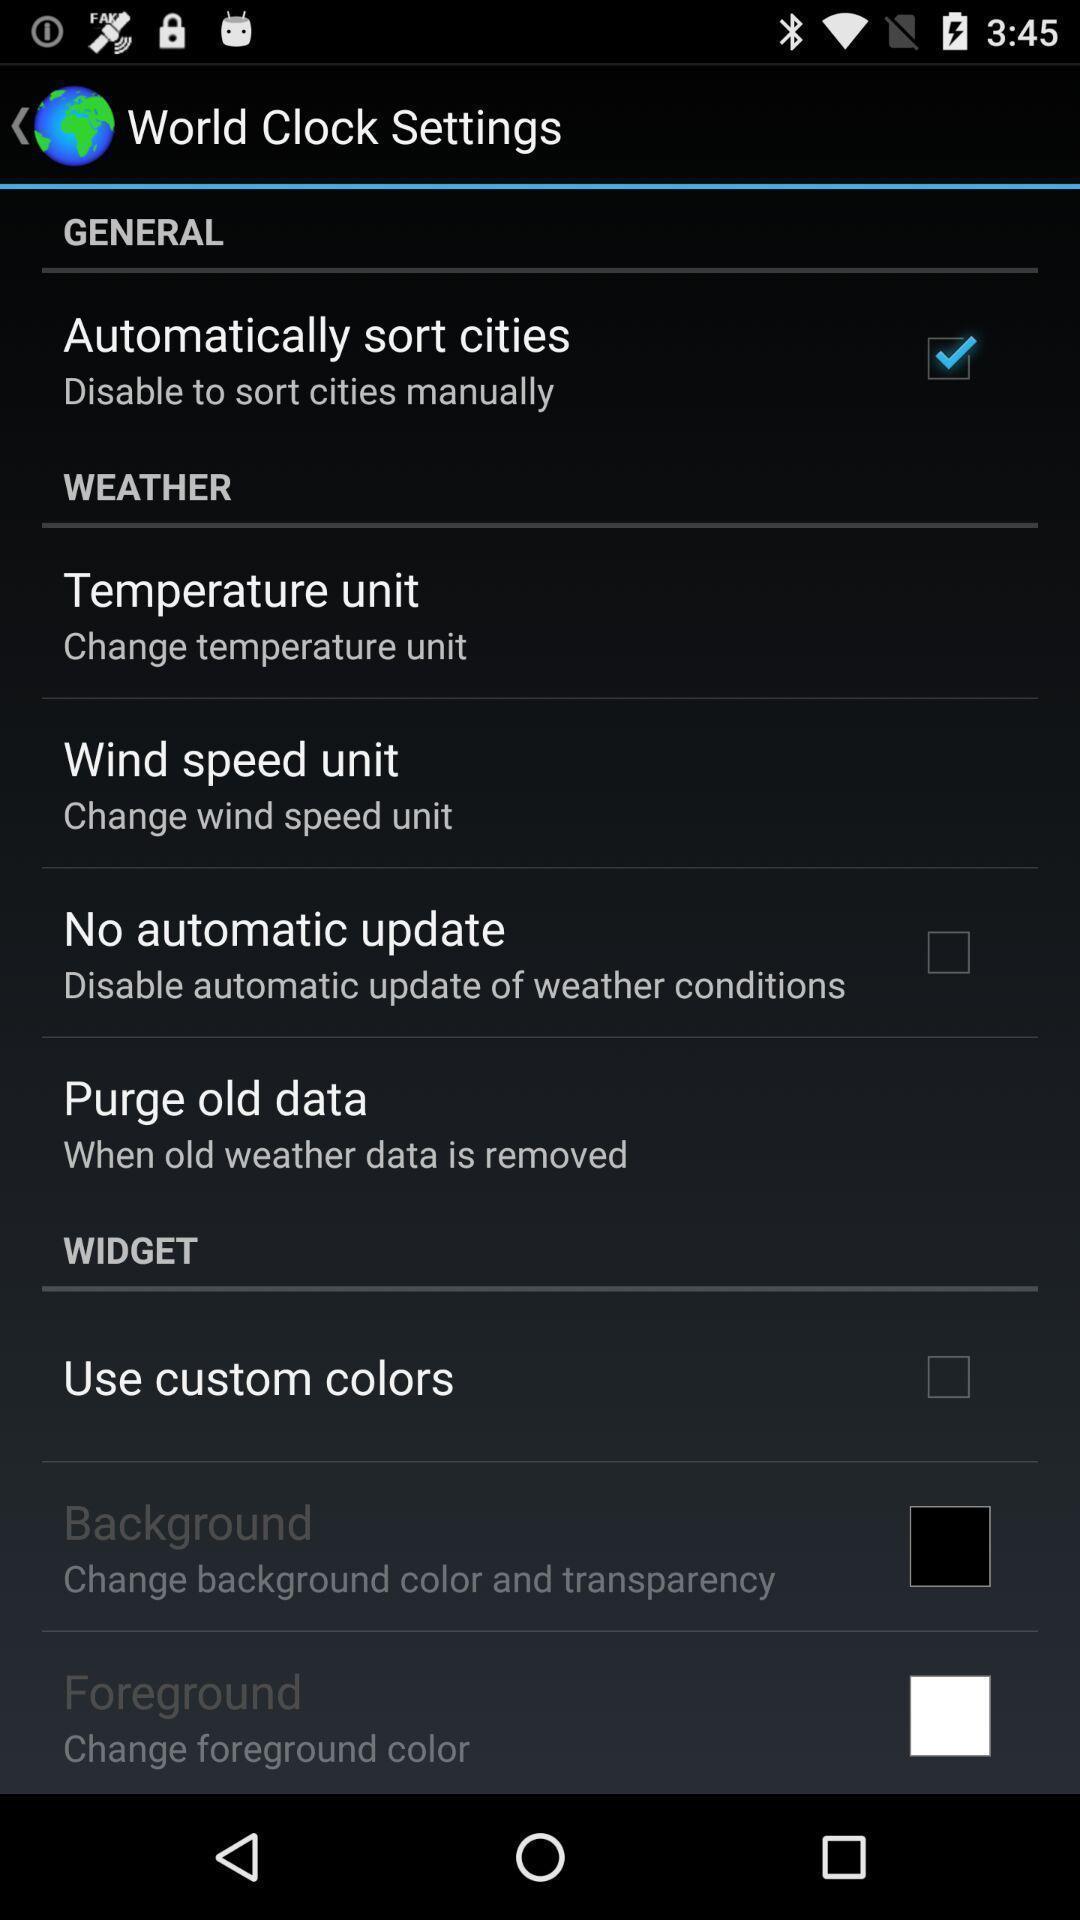What can you discern from this picture? Setting page displaying the various options in weather application. 